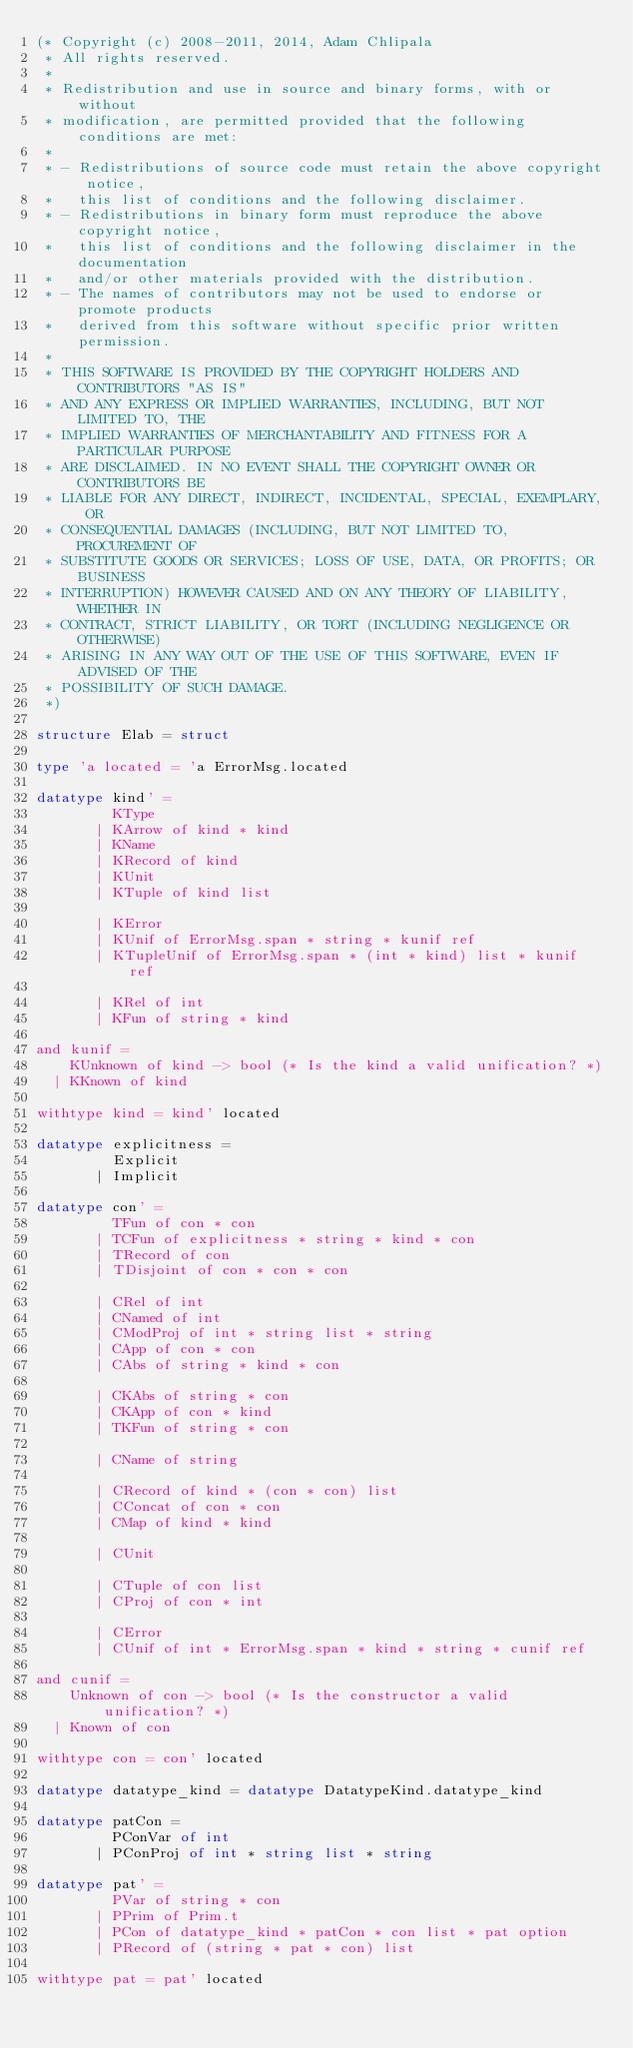<code> <loc_0><loc_0><loc_500><loc_500><_SML_>(* Copyright (c) 2008-2011, 2014, Adam Chlipala
 * All rights reserved.
 *
 * Redistribution and use in source and binary forms, with or without
 * modification, are permitted provided that the following conditions are met:
 *
 * - Redistributions of source code must retain the above copyright notice,
 *   this list of conditions and the following disclaimer.
 * - Redistributions in binary form must reproduce the above copyright notice,
 *   this list of conditions and the following disclaimer in the documentation
 *   and/or other materials provided with the distribution.
 * - The names of contributors may not be used to endorse or promote products
 *   derived from this software without specific prior written permission.
 *
 * THIS SOFTWARE IS PROVIDED BY THE COPYRIGHT HOLDERS AND CONTRIBUTORS "AS IS"
 * AND ANY EXPRESS OR IMPLIED WARRANTIES, INCLUDING, BUT NOT LIMITED TO, THE
 * IMPLIED WARRANTIES OF MERCHANTABILITY AND FITNESS FOR A PARTICULAR PURPOSE
 * ARE DISCLAIMED. IN NO EVENT SHALL THE COPYRIGHT OWNER OR CONTRIBUTORS BE
 * LIABLE FOR ANY DIRECT, INDIRECT, INCIDENTAL, SPECIAL, EXEMPLARY, OR 
 * CONSEQUENTIAL DAMAGES (INCLUDING, BUT NOT LIMITED TO, PROCUREMENT OF
 * SUBSTITUTE GOODS OR SERVICES; LOSS OF USE, DATA, OR PROFITS; OR BUSINESS
 * INTERRUPTION) HOWEVER CAUSED AND ON ANY THEORY OF LIABILITY, WHETHER IN
 * CONTRACT, STRICT LIABILITY, OR TORT (INCLUDING NEGLIGENCE OR OTHERWISE)
 * ARISING IN ANY WAY OUT OF THE USE OF THIS SOFTWARE, EVEN IF ADVISED OF THE
 * POSSIBILITY OF SUCH DAMAGE.
 *)

structure Elab = struct

type 'a located = 'a ErrorMsg.located

datatype kind' =
         KType
       | KArrow of kind * kind
       | KName
       | KRecord of kind
       | KUnit
       | KTuple of kind list

       | KError
       | KUnif of ErrorMsg.span * string * kunif ref
       | KTupleUnif of ErrorMsg.span * (int * kind) list * kunif ref

       | KRel of int
       | KFun of string * kind

and kunif =
    KUnknown of kind -> bool (* Is the kind a valid unification? *)
  | KKnown of kind

withtype kind = kind' located

datatype explicitness =
         Explicit
       | Implicit

datatype con' =
         TFun of con * con
       | TCFun of explicitness * string * kind * con
       | TRecord of con
       | TDisjoint of con * con * con

       | CRel of int
       | CNamed of int
       | CModProj of int * string list * string
       | CApp of con * con
       | CAbs of string * kind * con

       | CKAbs of string * con
       | CKApp of con * kind
       | TKFun of string * con

       | CName of string

       | CRecord of kind * (con * con) list
       | CConcat of con * con
       | CMap of kind * kind

       | CUnit

       | CTuple of con list
       | CProj of con * int

       | CError
       | CUnif of int * ErrorMsg.span * kind * string * cunif ref

and cunif =
    Unknown of con -> bool (* Is the constructor a valid unification? *)
  | Known of con

withtype con = con' located

datatype datatype_kind = datatype DatatypeKind.datatype_kind

datatype patCon =
         PConVar of int
       | PConProj of int * string list * string

datatype pat' =
         PVar of string * con
       | PPrim of Prim.t
       | PCon of datatype_kind * patCon * con list * pat option
       | PRecord of (string * pat * con) list

withtype pat = pat' located
</code> 